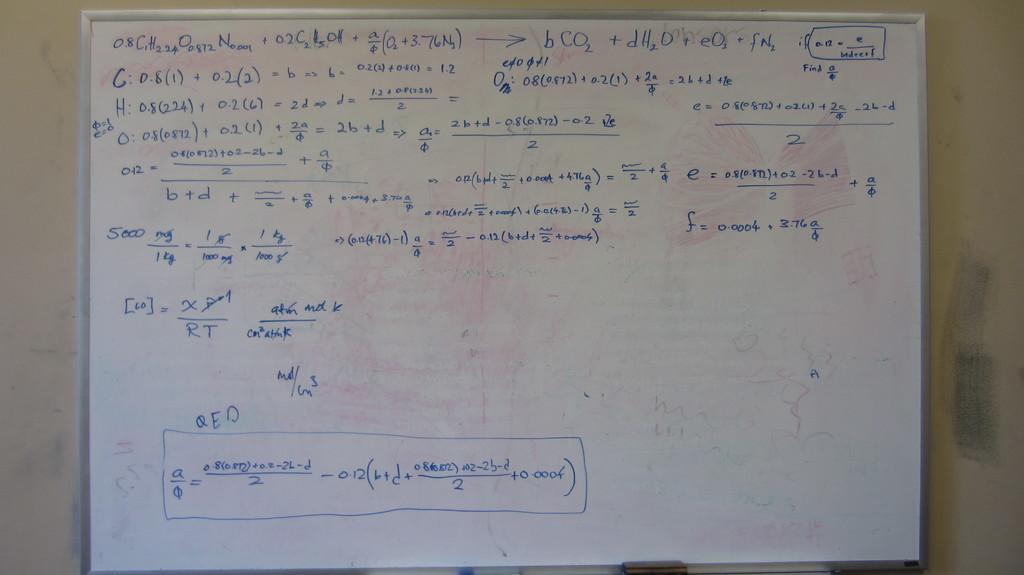What is the main object in the image? There is a white color board in the image. What is written or displayed on the white color board? There is text on the white color board. Is there a tray filled with rain visible in the image? No, there is no tray or rain present in the image. The image only features a white color board with text on it. 